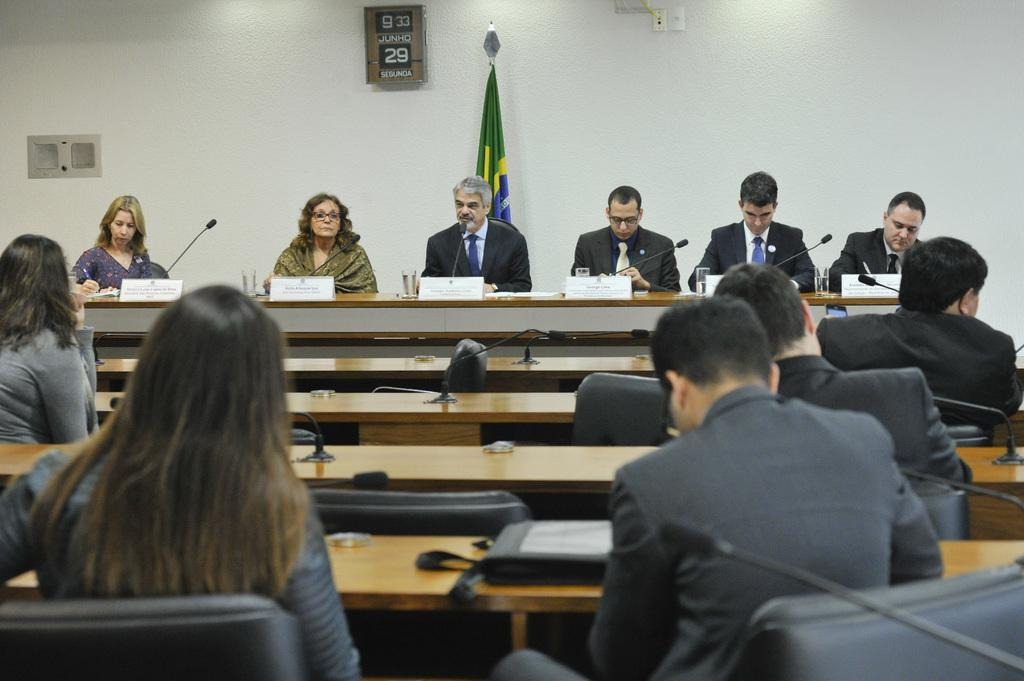Who or what can be seen in the image? There are people in the image. What type of objects are present on the tables in the image? There are tables with objects like microphones in the image. What type of furniture is visible in the image? There are chairs in the image. What can be seen on the wall in the image? There is a wall with objects like a digital calendar in the image. How much salt is on the wrist of the person in the image? There is no salt or mention of a wrist in the image; it features people, tables, chairs, and a wall with a digital calendar. 